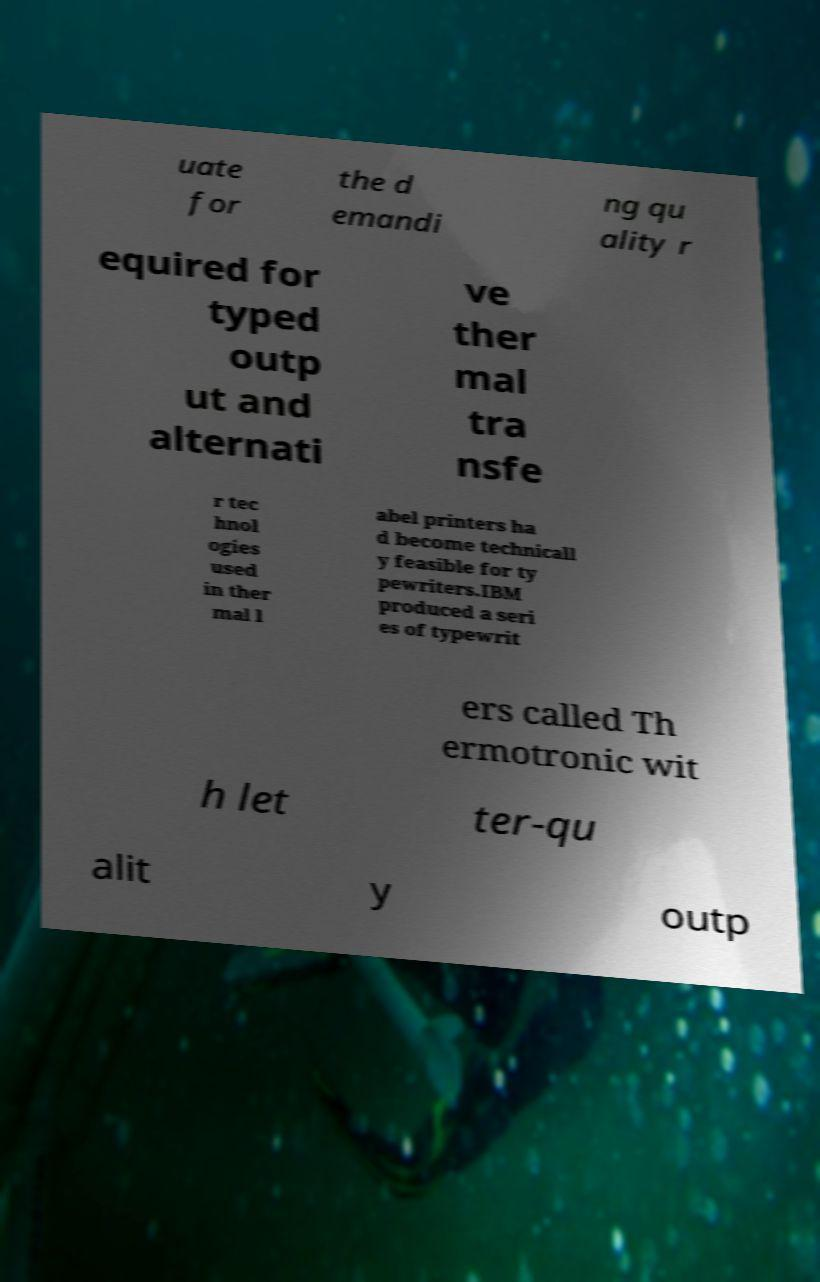For documentation purposes, I need the text within this image transcribed. Could you provide that? uate for the d emandi ng qu ality r equired for typed outp ut and alternati ve ther mal tra nsfe r tec hnol ogies used in ther mal l abel printers ha d become technicall y feasible for ty pewriters.IBM produced a seri es of typewrit ers called Th ermotronic wit h let ter-qu alit y outp 